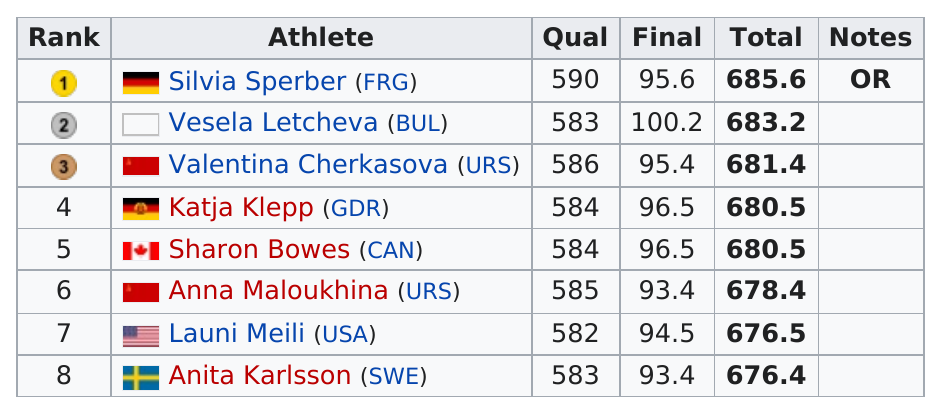List a handful of essential elements in this visual. There are 1 athlete from the US in the competition. Silvia Sperber of the Federal Republic of Germany is the runner who ran the most. What is the difference in qualifying for Sharon Bowes and Sylvia Sperber?" is a question asking for an explanation of the discrepancy between two things. Launi Meili is an athlete whose total score was not more than 680. The total number of points for the medal winners was 2050.2. 